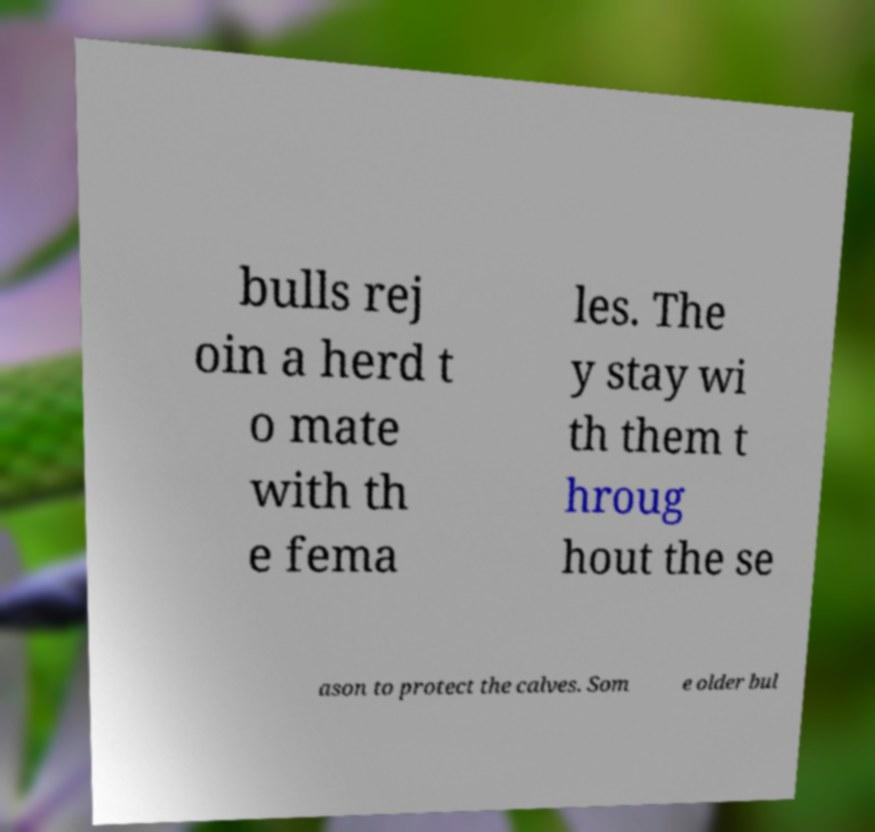Could you extract and type out the text from this image? bulls rej oin a herd t o mate with th e fema les. The y stay wi th them t hroug hout the se ason to protect the calves. Som e older bul 